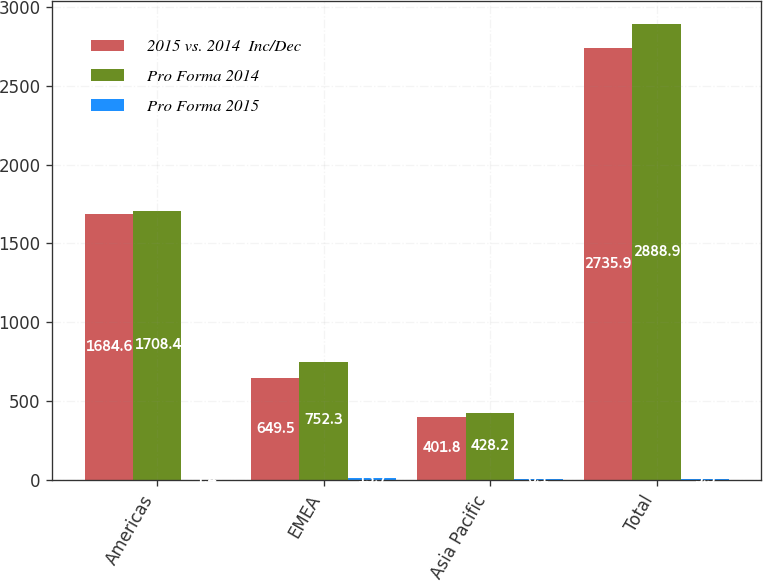<chart> <loc_0><loc_0><loc_500><loc_500><stacked_bar_chart><ecel><fcel>Americas<fcel>EMEA<fcel>Asia Pacific<fcel>Total<nl><fcel>2015 vs. 2014  Inc/Dec<fcel>1684.6<fcel>649.5<fcel>401.8<fcel>2735.9<nl><fcel>Pro Forma 2014<fcel>1708.4<fcel>752.3<fcel>428.2<fcel>2888.9<nl><fcel>Pro Forma 2015<fcel>1.4<fcel>13.7<fcel>6.1<fcel>5.3<nl></chart> 